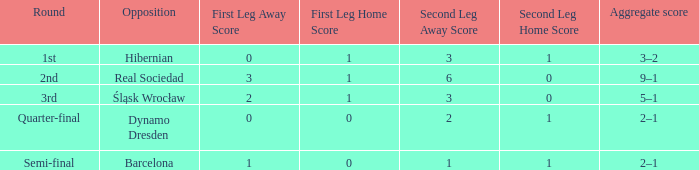What was the first leg against Hibernian? 0–1 (a). 